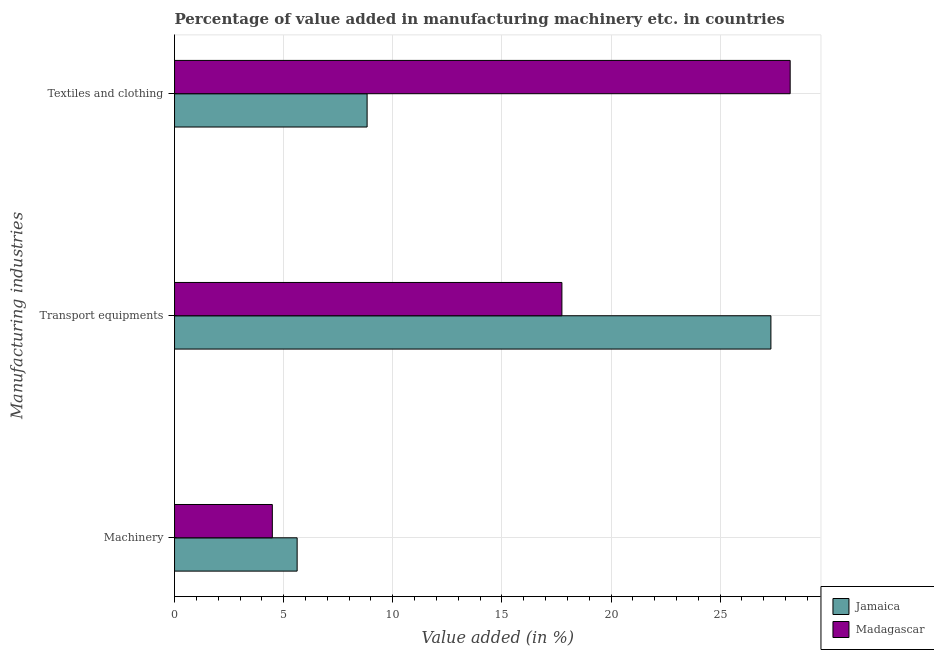How many groups of bars are there?
Provide a succinct answer. 3. Are the number of bars per tick equal to the number of legend labels?
Provide a short and direct response. Yes. Are the number of bars on each tick of the Y-axis equal?
Offer a very short reply. Yes. What is the label of the 1st group of bars from the top?
Offer a terse response. Textiles and clothing. What is the value added in manufacturing machinery in Jamaica?
Give a very brief answer. 5.62. Across all countries, what is the maximum value added in manufacturing textile and clothing?
Your response must be concise. 28.21. Across all countries, what is the minimum value added in manufacturing transport equipments?
Your answer should be compact. 17.75. In which country was the value added in manufacturing transport equipments maximum?
Your response must be concise. Jamaica. In which country was the value added in manufacturing textile and clothing minimum?
Keep it short and to the point. Jamaica. What is the total value added in manufacturing machinery in the graph?
Make the answer very short. 10.1. What is the difference between the value added in manufacturing machinery in Madagascar and that in Jamaica?
Ensure brevity in your answer.  -1.14. What is the difference between the value added in manufacturing machinery in Jamaica and the value added in manufacturing textile and clothing in Madagascar?
Offer a very short reply. -22.59. What is the average value added in manufacturing transport equipments per country?
Ensure brevity in your answer.  22.54. What is the difference between the value added in manufacturing transport equipments and value added in manufacturing machinery in Jamaica?
Your response must be concise. 21.71. In how many countries, is the value added in manufacturing machinery greater than 2 %?
Give a very brief answer. 2. What is the ratio of the value added in manufacturing machinery in Madagascar to that in Jamaica?
Keep it short and to the point. 0.8. Is the value added in manufacturing transport equipments in Madagascar less than that in Jamaica?
Keep it short and to the point. Yes. What is the difference between the highest and the second highest value added in manufacturing machinery?
Your answer should be compact. 1.14. What is the difference between the highest and the lowest value added in manufacturing textile and clothing?
Provide a short and direct response. 19.39. In how many countries, is the value added in manufacturing textile and clothing greater than the average value added in manufacturing textile and clothing taken over all countries?
Make the answer very short. 1. What does the 1st bar from the top in Textiles and clothing represents?
Give a very brief answer. Madagascar. What does the 2nd bar from the bottom in Textiles and clothing represents?
Your answer should be very brief. Madagascar. Are all the bars in the graph horizontal?
Provide a succinct answer. Yes. How many countries are there in the graph?
Offer a very short reply. 2. Are the values on the major ticks of X-axis written in scientific E-notation?
Keep it short and to the point. No. Does the graph contain any zero values?
Give a very brief answer. No. Where does the legend appear in the graph?
Make the answer very short. Bottom right. How many legend labels are there?
Ensure brevity in your answer.  2. How are the legend labels stacked?
Offer a very short reply. Vertical. What is the title of the graph?
Keep it short and to the point. Percentage of value added in manufacturing machinery etc. in countries. Does "Sri Lanka" appear as one of the legend labels in the graph?
Your answer should be compact. No. What is the label or title of the X-axis?
Your answer should be compact. Value added (in %). What is the label or title of the Y-axis?
Offer a very short reply. Manufacturing industries. What is the Value added (in %) of Jamaica in Machinery?
Your answer should be compact. 5.62. What is the Value added (in %) in Madagascar in Machinery?
Your answer should be compact. 4.48. What is the Value added (in %) in Jamaica in Transport equipments?
Keep it short and to the point. 27.33. What is the Value added (in %) in Madagascar in Transport equipments?
Offer a terse response. 17.75. What is the Value added (in %) in Jamaica in Textiles and clothing?
Provide a succinct answer. 8.82. What is the Value added (in %) of Madagascar in Textiles and clothing?
Provide a short and direct response. 28.21. Across all Manufacturing industries, what is the maximum Value added (in %) in Jamaica?
Make the answer very short. 27.33. Across all Manufacturing industries, what is the maximum Value added (in %) in Madagascar?
Make the answer very short. 28.21. Across all Manufacturing industries, what is the minimum Value added (in %) in Jamaica?
Your answer should be very brief. 5.62. Across all Manufacturing industries, what is the minimum Value added (in %) in Madagascar?
Your answer should be compact. 4.48. What is the total Value added (in %) of Jamaica in the graph?
Offer a very short reply. 41.77. What is the total Value added (in %) in Madagascar in the graph?
Provide a short and direct response. 50.44. What is the difference between the Value added (in %) in Jamaica in Machinery and that in Transport equipments?
Provide a succinct answer. -21.71. What is the difference between the Value added (in %) of Madagascar in Machinery and that in Transport equipments?
Your response must be concise. -13.27. What is the difference between the Value added (in %) of Jamaica in Machinery and that in Textiles and clothing?
Provide a short and direct response. -3.21. What is the difference between the Value added (in %) of Madagascar in Machinery and that in Textiles and clothing?
Provide a short and direct response. -23.73. What is the difference between the Value added (in %) in Jamaica in Transport equipments and that in Textiles and clothing?
Offer a very short reply. 18.5. What is the difference between the Value added (in %) of Madagascar in Transport equipments and that in Textiles and clothing?
Your answer should be compact. -10.46. What is the difference between the Value added (in %) of Jamaica in Machinery and the Value added (in %) of Madagascar in Transport equipments?
Give a very brief answer. -12.13. What is the difference between the Value added (in %) in Jamaica in Machinery and the Value added (in %) in Madagascar in Textiles and clothing?
Your response must be concise. -22.59. What is the difference between the Value added (in %) of Jamaica in Transport equipments and the Value added (in %) of Madagascar in Textiles and clothing?
Keep it short and to the point. -0.88. What is the average Value added (in %) of Jamaica per Manufacturing industries?
Your answer should be compact. 13.92. What is the average Value added (in %) of Madagascar per Manufacturing industries?
Keep it short and to the point. 16.81. What is the difference between the Value added (in %) in Jamaica and Value added (in %) in Madagascar in Machinery?
Provide a succinct answer. 1.14. What is the difference between the Value added (in %) in Jamaica and Value added (in %) in Madagascar in Transport equipments?
Your answer should be very brief. 9.58. What is the difference between the Value added (in %) of Jamaica and Value added (in %) of Madagascar in Textiles and clothing?
Make the answer very short. -19.39. What is the ratio of the Value added (in %) in Jamaica in Machinery to that in Transport equipments?
Ensure brevity in your answer.  0.21. What is the ratio of the Value added (in %) in Madagascar in Machinery to that in Transport equipments?
Ensure brevity in your answer.  0.25. What is the ratio of the Value added (in %) in Jamaica in Machinery to that in Textiles and clothing?
Offer a terse response. 0.64. What is the ratio of the Value added (in %) in Madagascar in Machinery to that in Textiles and clothing?
Give a very brief answer. 0.16. What is the ratio of the Value added (in %) in Jamaica in Transport equipments to that in Textiles and clothing?
Provide a short and direct response. 3.1. What is the ratio of the Value added (in %) of Madagascar in Transport equipments to that in Textiles and clothing?
Make the answer very short. 0.63. What is the difference between the highest and the second highest Value added (in %) of Jamaica?
Provide a short and direct response. 18.5. What is the difference between the highest and the second highest Value added (in %) of Madagascar?
Provide a short and direct response. 10.46. What is the difference between the highest and the lowest Value added (in %) of Jamaica?
Provide a succinct answer. 21.71. What is the difference between the highest and the lowest Value added (in %) of Madagascar?
Make the answer very short. 23.73. 